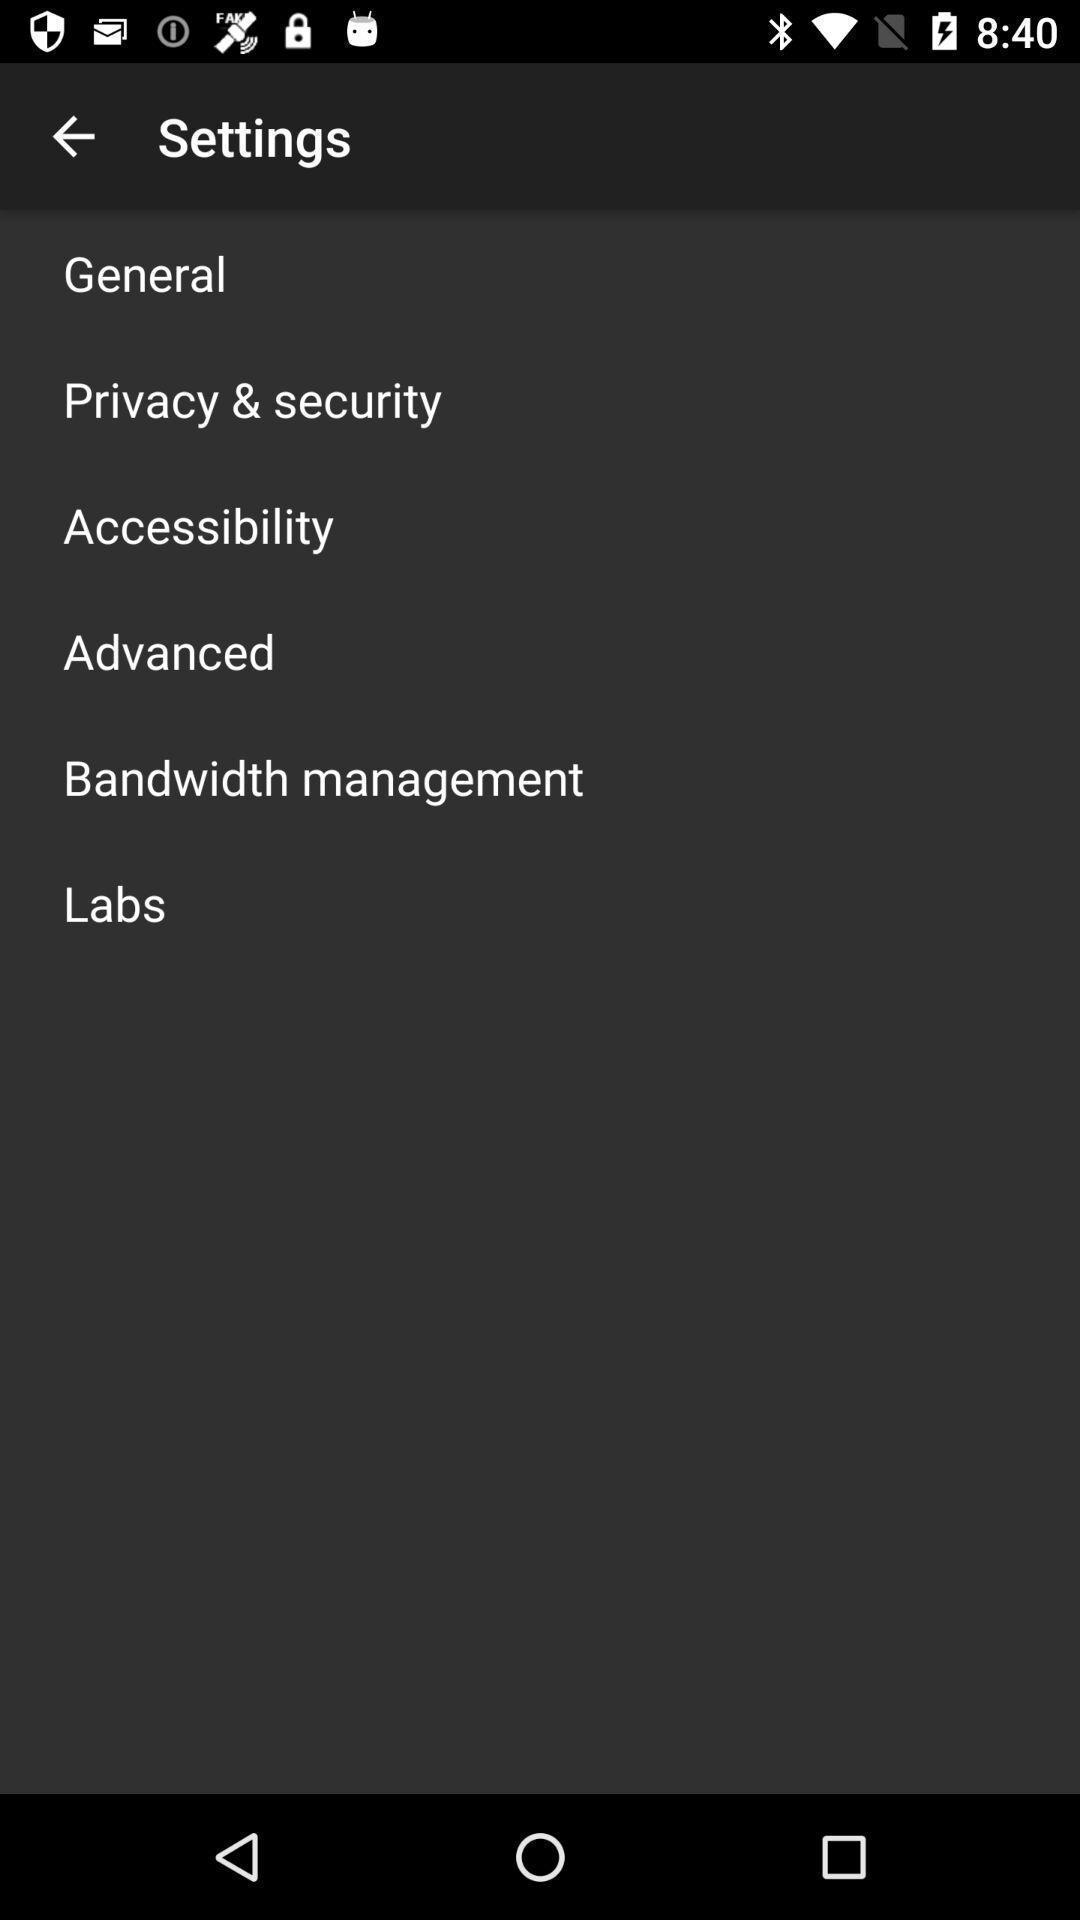Tell me what you see in this picture. Settings tab with different options in the mobile. 